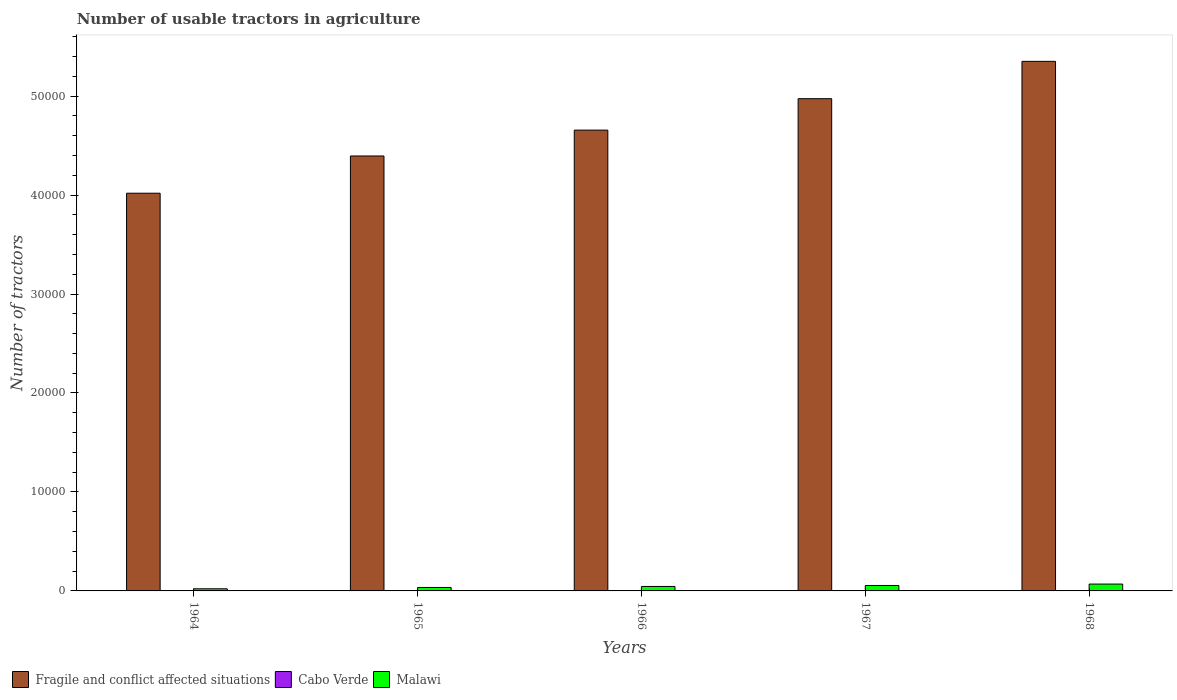How many different coloured bars are there?
Your answer should be compact. 3. How many groups of bars are there?
Keep it short and to the point. 5. How many bars are there on the 2nd tick from the left?
Your answer should be compact. 3. How many bars are there on the 2nd tick from the right?
Provide a succinct answer. 3. What is the label of the 1st group of bars from the left?
Provide a short and direct response. 1964. In how many cases, is the number of bars for a given year not equal to the number of legend labels?
Offer a terse response. 0. What is the number of usable tractors in agriculture in Fragile and conflict affected situations in 1967?
Ensure brevity in your answer.  4.97e+04. Across all years, what is the maximum number of usable tractors in agriculture in Fragile and conflict affected situations?
Offer a very short reply. 5.35e+04. Across all years, what is the minimum number of usable tractors in agriculture in Cabo Verde?
Make the answer very short. 3. In which year was the number of usable tractors in agriculture in Fragile and conflict affected situations maximum?
Your answer should be compact. 1968. In which year was the number of usable tractors in agriculture in Cabo Verde minimum?
Make the answer very short. 1964. What is the total number of usable tractors in agriculture in Cabo Verde in the graph?
Your answer should be very brief. 17. What is the difference between the number of usable tractors in agriculture in Malawi in 1966 and that in 1968?
Your response must be concise. -242. What is the difference between the number of usable tractors in agriculture in Malawi in 1968 and the number of usable tractors in agriculture in Cabo Verde in 1966?
Give a very brief answer. 689. What is the average number of usable tractors in agriculture in Cabo Verde per year?
Provide a short and direct response. 3.4. In the year 1965, what is the difference between the number of usable tractors in agriculture in Cabo Verde and number of usable tractors in agriculture in Fragile and conflict affected situations?
Offer a very short reply. -4.39e+04. Is the number of usable tractors in agriculture in Fragile and conflict affected situations in 1965 less than that in 1968?
Give a very brief answer. Yes. What is the difference between the highest and the second highest number of usable tractors in agriculture in Malawi?
Give a very brief answer. 142. What is the difference between the highest and the lowest number of usable tractors in agriculture in Malawi?
Ensure brevity in your answer.  477. In how many years, is the number of usable tractors in agriculture in Cabo Verde greater than the average number of usable tractors in agriculture in Cabo Verde taken over all years?
Your response must be concise. 2. Is the sum of the number of usable tractors in agriculture in Fragile and conflict affected situations in 1966 and 1967 greater than the maximum number of usable tractors in agriculture in Cabo Verde across all years?
Your response must be concise. Yes. What does the 3rd bar from the left in 1964 represents?
Your answer should be compact. Malawi. What does the 2nd bar from the right in 1966 represents?
Make the answer very short. Cabo Verde. Are all the bars in the graph horizontal?
Ensure brevity in your answer.  No. How many years are there in the graph?
Your answer should be very brief. 5. What is the difference between two consecutive major ticks on the Y-axis?
Provide a short and direct response. 10000. Where does the legend appear in the graph?
Make the answer very short. Bottom left. How many legend labels are there?
Provide a short and direct response. 3. What is the title of the graph?
Offer a very short reply. Number of usable tractors in agriculture. Does "Cuba" appear as one of the legend labels in the graph?
Keep it short and to the point. No. What is the label or title of the Y-axis?
Your answer should be compact. Number of tractors. What is the Number of tractors in Fragile and conflict affected situations in 1964?
Offer a terse response. 4.02e+04. What is the Number of tractors of Cabo Verde in 1964?
Provide a succinct answer. 3. What is the Number of tractors in Malawi in 1964?
Offer a terse response. 215. What is the Number of tractors of Fragile and conflict affected situations in 1965?
Give a very brief answer. 4.39e+04. What is the Number of tractors of Malawi in 1965?
Your answer should be very brief. 350. What is the Number of tractors of Fragile and conflict affected situations in 1966?
Offer a terse response. 4.66e+04. What is the Number of tractors in Cabo Verde in 1966?
Provide a succinct answer. 3. What is the Number of tractors of Malawi in 1966?
Provide a short and direct response. 450. What is the Number of tractors in Fragile and conflict affected situations in 1967?
Ensure brevity in your answer.  4.97e+04. What is the Number of tractors of Malawi in 1967?
Give a very brief answer. 550. What is the Number of tractors of Fragile and conflict affected situations in 1968?
Your answer should be very brief. 5.35e+04. What is the Number of tractors in Cabo Verde in 1968?
Make the answer very short. 4. What is the Number of tractors in Malawi in 1968?
Make the answer very short. 692. Across all years, what is the maximum Number of tractors of Fragile and conflict affected situations?
Make the answer very short. 5.35e+04. Across all years, what is the maximum Number of tractors in Malawi?
Ensure brevity in your answer.  692. Across all years, what is the minimum Number of tractors in Fragile and conflict affected situations?
Offer a terse response. 4.02e+04. Across all years, what is the minimum Number of tractors in Cabo Verde?
Make the answer very short. 3. Across all years, what is the minimum Number of tractors in Malawi?
Your answer should be very brief. 215. What is the total Number of tractors in Fragile and conflict affected situations in the graph?
Provide a short and direct response. 2.34e+05. What is the total Number of tractors in Cabo Verde in the graph?
Make the answer very short. 17. What is the total Number of tractors in Malawi in the graph?
Provide a succinct answer. 2257. What is the difference between the Number of tractors in Fragile and conflict affected situations in 1964 and that in 1965?
Ensure brevity in your answer.  -3761. What is the difference between the Number of tractors in Malawi in 1964 and that in 1965?
Provide a short and direct response. -135. What is the difference between the Number of tractors in Fragile and conflict affected situations in 1964 and that in 1966?
Give a very brief answer. -6375. What is the difference between the Number of tractors in Malawi in 1964 and that in 1966?
Your response must be concise. -235. What is the difference between the Number of tractors of Fragile and conflict affected situations in 1964 and that in 1967?
Keep it short and to the point. -9550. What is the difference between the Number of tractors of Cabo Verde in 1964 and that in 1967?
Give a very brief answer. -1. What is the difference between the Number of tractors of Malawi in 1964 and that in 1967?
Offer a very short reply. -335. What is the difference between the Number of tractors of Fragile and conflict affected situations in 1964 and that in 1968?
Your answer should be compact. -1.33e+04. What is the difference between the Number of tractors in Cabo Verde in 1964 and that in 1968?
Your response must be concise. -1. What is the difference between the Number of tractors in Malawi in 1964 and that in 1968?
Give a very brief answer. -477. What is the difference between the Number of tractors of Fragile and conflict affected situations in 1965 and that in 1966?
Offer a very short reply. -2614. What is the difference between the Number of tractors in Cabo Verde in 1965 and that in 1966?
Provide a short and direct response. 0. What is the difference between the Number of tractors in Malawi in 1965 and that in 1966?
Give a very brief answer. -100. What is the difference between the Number of tractors in Fragile and conflict affected situations in 1965 and that in 1967?
Give a very brief answer. -5789. What is the difference between the Number of tractors of Cabo Verde in 1965 and that in 1967?
Your response must be concise. -1. What is the difference between the Number of tractors in Malawi in 1965 and that in 1967?
Keep it short and to the point. -200. What is the difference between the Number of tractors of Fragile and conflict affected situations in 1965 and that in 1968?
Your answer should be very brief. -9561. What is the difference between the Number of tractors in Cabo Verde in 1965 and that in 1968?
Offer a terse response. -1. What is the difference between the Number of tractors of Malawi in 1965 and that in 1968?
Your response must be concise. -342. What is the difference between the Number of tractors in Fragile and conflict affected situations in 1966 and that in 1967?
Your answer should be compact. -3175. What is the difference between the Number of tractors in Cabo Verde in 1966 and that in 1967?
Make the answer very short. -1. What is the difference between the Number of tractors of Malawi in 1966 and that in 1967?
Make the answer very short. -100. What is the difference between the Number of tractors of Fragile and conflict affected situations in 1966 and that in 1968?
Keep it short and to the point. -6947. What is the difference between the Number of tractors of Malawi in 1966 and that in 1968?
Your answer should be very brief. -242. What is the difference between the Number of tractors of Fragile and conflict affected situations in 1967 and that in 1968?
Offer a terse response. -3772. What is the difference between the Number of tractors in Cabo Verde in 1967 and that in 1968?
Keep it short and to the point. 0. What is the difference between the Number of tractors of Malawi in 1967 and that in 1968?
Your answer should be compact. -142. What is the difference between the Number of tractors of Fragile and conflict affected situations in 1964 and the Number of tractors of Cabo Verde in 1965?
Your answer should be compact. 4.02e+04. What is the difference between the Number of tractors in Fragile and conflict affected situations in 1964 and the Number of tractors in Malawi in 1965?
Offer a terse response. 3.98e+04. What is the difference between the Number of tractors in Cabo Verde in 1964 and the Number of tractors in Malawi in 1965?
Provide a succinct answer. -347. What is the difference between the Number of tractors of Fragile and conflict affected situations in 1964 and the Number of tractors of Cabo Verde in 1966?
Your response must be concise. 4.02e+04. What is the difference between the Number of tractors in Fragile and conflict affected situations in 1964 and the Number of tractors in Malawi in 1966?
Your answer should be very brief. 3.97e+04. What is the difference between the Number of tractors in Cabo Verde in 1964 and the Number of tractors in Malawi in 1966?
Provide a short and direct response. -447. What is the difference between the Number of tractors in Fragile and conflict affected situations in 1964 and the Number of tractors in Cabo Verde in 1967?
Give a very brief answer. 4.02e+04. What is the difference between the Number of tractors of Fragile and conflict affected situations in 1964 and the Number of tractors of Malawi in 1967?
Your response must be concise. 3.96e+04. What is the difference between the Number of tractors in Cabo Verde in 1964 and the Number of tractors in Malawi in 1967?
Ensure brevity in your answer.  -547. What is the difference between the Number of tractors in Fragile and conflict affected situations in 1964 and the Number of tractors in Cabo Verde in 1968?
Keep it short and to the point. 4.02e+04. What is the difference between the Number of tractors in Fragile and conflict affected situations in 1964 and the Number of tractors in Malawi in 1968?
Offer a very short reply. 3.95e+04. What is the difference between the Number of tractors of Cabo Verde in 1964 and the Number of tractors of Malawi in 1968?
Offer a terse response. -689. What is the difference between the Number of tractors of Fragile and conflict affected situations in 1965 and the Number of tractors of Cabo Verde in 1966?
Your response must be concise. 4.39e+04. What is the difference between the Number of tractors of Fragile and conflict affected situations in 1965 and the Number of tractors of Malawi in 1966?
Offer a very short reply. 4.35e+04. What is the difference between the Number of tractors in Cabo Verde in 1965 and the Number of tractors in Malawi in 1966?
Provide a succinct answer. -447. What is the difference between the Number of tractors of Fragile and conflict affected situations in 1965 and the Number of tractors of Cabo Verde in 1967?
Provide a short and direct response. 4.39e+04. What is the difference between the Number of tractors in Fragile and conflict affected situations in 1965 and the Number of tractors in Malawi in 1967?
Provide a succinct answer. 4.34e+04. What is the difference between the Number of tractors of Cabo Verde in 1965 and the Number of tractors of Malawi in 1967?
Offer a very short reply. -547. What is the difference between the Number of tractors of Fragile and conflict affected situations in 1965 and the Number of tractors of Cabo Verde in 1968?
Your answer should be very brief. 4.39e+04. What is the difference between the Number of tractors of Fragile and conflict affected situations in 1965 and the Number of tractors of Malawi in 1968?
Make the answer very short. 4.33e+04. What is the difference between the Number of tractors in Cabo Verde in 1965 and the Number of tractors in Malawi in 1968?
Your answer should be compact. -689. What is the difference between the Number of tractors in Fragile and conflict affected situations in 1966 and the Number of tractors in Cabo Verde in 1967?
Offer a terse response. 4.66e+04. What is the difference between the Number of tractors in Fragile and conflict affected situations in 1966 and the Number of tractors in Malawi in 1967?
Offer a terse response. 4.60e+04. What is the difference between the Number of tractors in Cabo Verde in 1966 and the Number of tractors in Malawi in 1967?
Make the answer very short. -547. What is the difference between the Number of tractors in Fragile and conflict affected situations in 1966 and the Number of tractors in Cabo Verde in 1968?
Ensure brevity in your answer.  4.66e+04. What is the difference between the Number of tractors of Fragile and conflict affected situations in 1966 and the Number of tractors of Malawi in 1968?
Ensure brevity in your answer.  4.59e+04. What is the difference between the Number of tractors of Cabo Verde in 1966 and the Number of tractors of Malawi in 1968?
Give a very brief answer. -689. What is the difference between the Number of tractors in Fragile and conflict affected situations in 1967 and the Number of tractors in Cabo Verde in 1968?
Your answer should be compact. 4.97e+04. What is the difference between the Number of tractors in Fragile and conflict affected situations in 1967 and the Number of tractors in Malawi in 1968?
Keep it short and to the point. 4.90e+04. What is the difference between the Number of tractors of Cabo Verde in 1967 and the Number of tractors of Malawi in 1968?
Give a very brief answer. -688. What is the average Number of tractors in Fragile and conflict affected situations per year?
Give a very brief answer. 4.68e+04. What is the average Number of tractors in Malawi per year?
Give a very brief answer. 451.4. In the year 1964, what is the difference between the Number of tractors of Fragile and conflict affected situations and Number of tractors of Cabo Verde?
Your response must be concise. 4.02e+04. In the year 1964, what is the difference between the Number of tractors of Fragile and conflict affected situations and Number of tractors of Malawi?
Offer a terse response. 4.00e+04. In the year 1964, what is the difference between the Number of tractors in Cabo Verde and Number of tractors in Malawi?
Ensure brevity in your answer.  -212. In the year 1965, what is the difference between the Number of tractors of Fragile and conflict affected situations and Number of tractors of Cabo Verde?
Ensure brevity in your answer.  4.39e+04. In the year 1965, what is the difference between the Number of tractors of Fragile and conflict affected situations and Number of tractors of Malawi?
Ensure brevity in your answer.  4.36e+04. In the year 1965, what is the difference between the Number of tractors of Cabo Verde and Number of tractors of Malawi?
Your answer should be very brief. -347. In the year 1966, what is the difference between the Number of tractors in Fragile and conflict affected situations and Number of tractors in Cabo Verde?
Your answer should be very brief. 4.66e+04. In the year 1966, what is the difference between the Number of tractors in Fragile and conflict affected situations and Number of tractors in Malawi?
Make the answer very short. 4.61e+04. In the year 1966, what is the difference between the Number of tractors of Cabo Verde and Number of tractors of Malawi?
Ensure brevity in your answer.  -447. In the year 1967, what is the difference between the Number of tractors in Fragile and conflict affected situations and Number of tractors in Cabo Verde?
Provide a short and direct response. 4.97e+04. In the year 1967, what is the difference between the Number of tractors of Fragile and conflict affected situations and Number of tractors of Malawi?
Ensure brevity in your answer.  4.92e+04. In the year 1967, what is the difference between the Number of tractors in Cabo Verde and Number of tractors in Malawi?
Give a very brief answer. -546. In the year 1968, what is the difference between the Number of tractors of Fragile and conflict affected situations and Number of tractors of Cabo Verde?
Provide a succinct answer. 5.35e+04. In the year 1968, what is the difference between the Number of tractors of Fragile and conflict affected situations and Number of tractors of Malawi?
Provide a succinct answer. 5.28e+04. In the year 1968, what is the difference between the Number of tractors in Cabo Verde and Number of tractors in Malawi?
Make the answer very short. -688. What is the ratio of the Number of tractors of Fragile and conflict affected situations in 1964 to that in 1965?
Your answer should be compact. 0.91. What is the ratio of the Number of tractors in Cabo Verde in 1964 to that in 1965?
Provide a succinct answer. 1. What is the ratio of the Number of tractors of Malawi in 1964 to that in 1965?
Provide a short and direct response. 0.61. What is the ratio of the Number of tractors in Fragile and conflict affected situations in 1964 to that in 1966?
Your response must be concise. 0.86. What is the ratio of the Number of tractors in Cabo Verde in 1964 to that in 1966?
Provide a short and direct response. 1. What is the ratio of the Number of tractors of Malawi in 1964 to that in 1966?
Your response must be concise. 0.48. What is the ratio of the Number of tractors of Fragile and conflict affected situations in 1964 to that in 1967?
Provide a short and direct response. 0.81. What is the ratio of the Number of tractors in Cabo Verde in 1964 to that in 1967?
Your answer should be very brief. 0.75. What is the ratio of the Number of tractors in Malawi in 1964 to that in 1967?
Your answer should be very brief. 0.39. What is the ratio of the Number of tractors of Fragile and conflict affected situations in 1964 to that in 1968?
Your answer should be compact. 0.75. What is the ratio of the Number of tractors of Cabo Verde in 1964 to that in 1968?
Keep it short and to the point. 0.75. What is the ratio of the Number of tractors in Malawi in 1964 to that in 1968?
Offer a terse response. 0.31. What is the ratio of the Number of tractors of Fragile and conflict affected situations in 1965 to that in 1966?
Provide a short and direct response. 0.94. What is the ratio of the Number of tractors in Malawi in 1965 to that in 1966?
Make the answer very short. 0.78. What is the ratio of the Number of tractors of Fragile and conflict affected situations in 1965 to that in 1967?
Keep it short and to the point. 0.88. What is the ratio of the Number of tractors in Cabo Verde in 1965 to that in 1967?
Provide a succinct answer. 0.75. What is the ratio of the Number of tractors in Malawi in 1965 to that in 1967?
Offer a very short reply. 0.64. What is the ratio of the Number of tractors in Fragile and conflict affected situations in 1965 to that in 1968?
Provide a short and direct response. 0.82. What is the ratio of the Number of tractors in Cabo Verde in 1965 to that in 1968?
Provide a succinct answer. 0.75. What is the ratio of the Number of tractors in Malawi in 1965 to that in 1968?
Offer a very short reply. 0.51. What is the ratio of the Number of tractors in Fragile and conflict affected situations in 1966 to that in 1967?
Provide a succinct answer. 0.94. What is the ratio of the Number of tractors in Cabo Verde in 1966 to that in 1967?
Your response must be concise. 0.75. What is the ratio of the Number of tractors in Malawi in 1966 to that in 1967?
Your answer should be very brief. 0.82. What is the ratio of the Number of tractors in Fragile and conflict affected situations in 1966 to that in 1968?
Your answer should be compact. 0.87. What is the ratio of the Number of tractors in Malawi in 1966 to that in 1968?
Make the answer very short. 0.65. What is the ratio of the Number of tractors in Fragile and conflict affected situations in 1967 to that in 1968?
Offer a terse response. 0.93. What is the ratio of the Number of tractors in Malawi in 1967 to that in 1968?
Keep it short and to the point. 0.79. What is the difference between the highest and the second highest Number of tractors of Fragile and conflict affected situations?
Keep it short and to the point. 3772. What is the difference between the highest and the second highest Number of tractors of Cabo Verde?
Provide a short and direct response. 0. What is the difference between the highest and the second highest Number of tractors in Malawi?
Give a very brief answer. 142. What is the difference between the highest and the lowest Number of tractors in Fragile and conflict affected situations?
Your answer should be compact. 1.33e+04. What is the difference between the highest and the lowest Number of tractors of Malawi?
Provide a short and direct response. 477. 